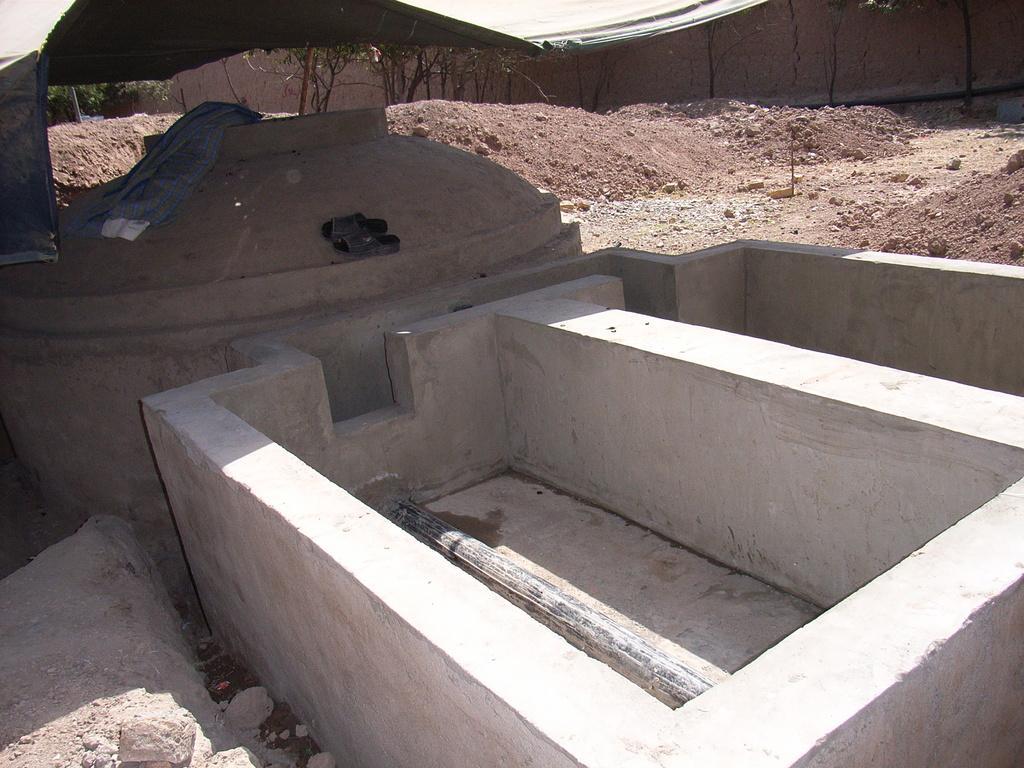How would you summarize this image in a sentence or two? In this image we can see a concrete blocks, there are stones, there is the mud, there is a wall, there are trees. 